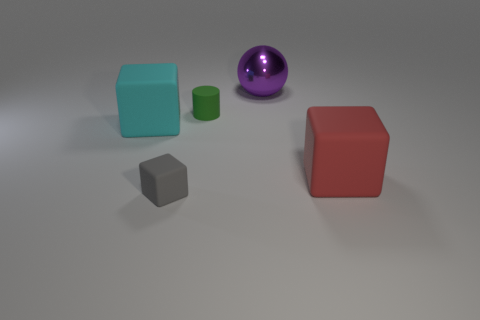Subtract 1 blocks. How many blocks are left? 2 Add 4 red matte things. How many objects exist? 9 Subtract all cubes. How many objects are left? 2 Add 4 gray rubber things. How many gray rubber things exist? 5 Subtract 0 purple cylinders. How many objects are left? 5 Subtract all green cylinders. Subtract all matte cubes. How many objects are left? 1 Add 4 gray rubber objects. How many gray rubber objects are left? 5 